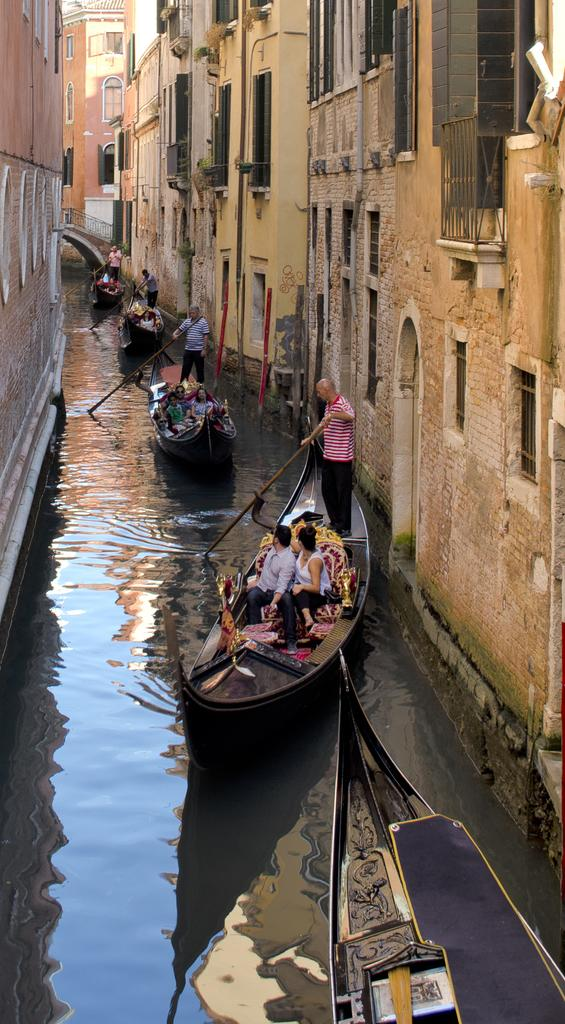What is the main feature of the image? There is a river in the image. How is the river positioned in relation to the buildings? The river is between buildings. What is happening on the river in the image? There are boats moving on the river. What type of lamp is being used by the spy in the image? There is no spy or lamp present in the image. The image features a river with boats moving between buildings. 